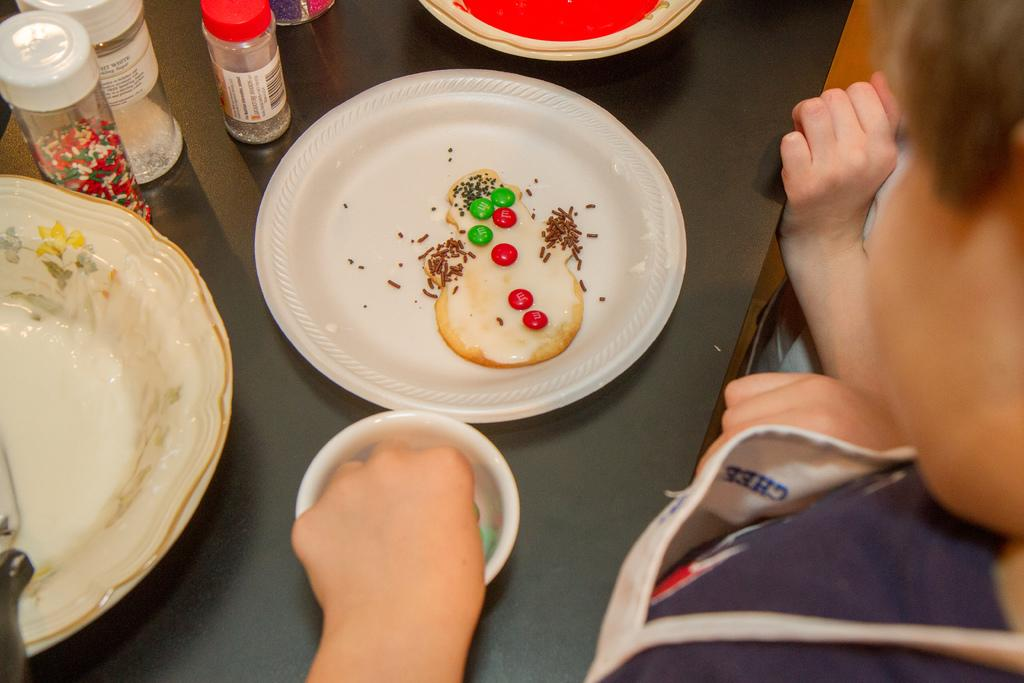How many people are in the foreground of the image? There are two persons in the foreground of the image. What are the two persons doing in the image? The two persons are standing. What is located behind the two persons? The persons are in front of a table. What can be seen on the table in the image? There are platters, a platter with food, a bowl, and containers on the table. What type of spark can be seen coming from the toe of one of the persons in the image? There is no spark or toe visible in the image; the persons are standing in front of a table with various items. 